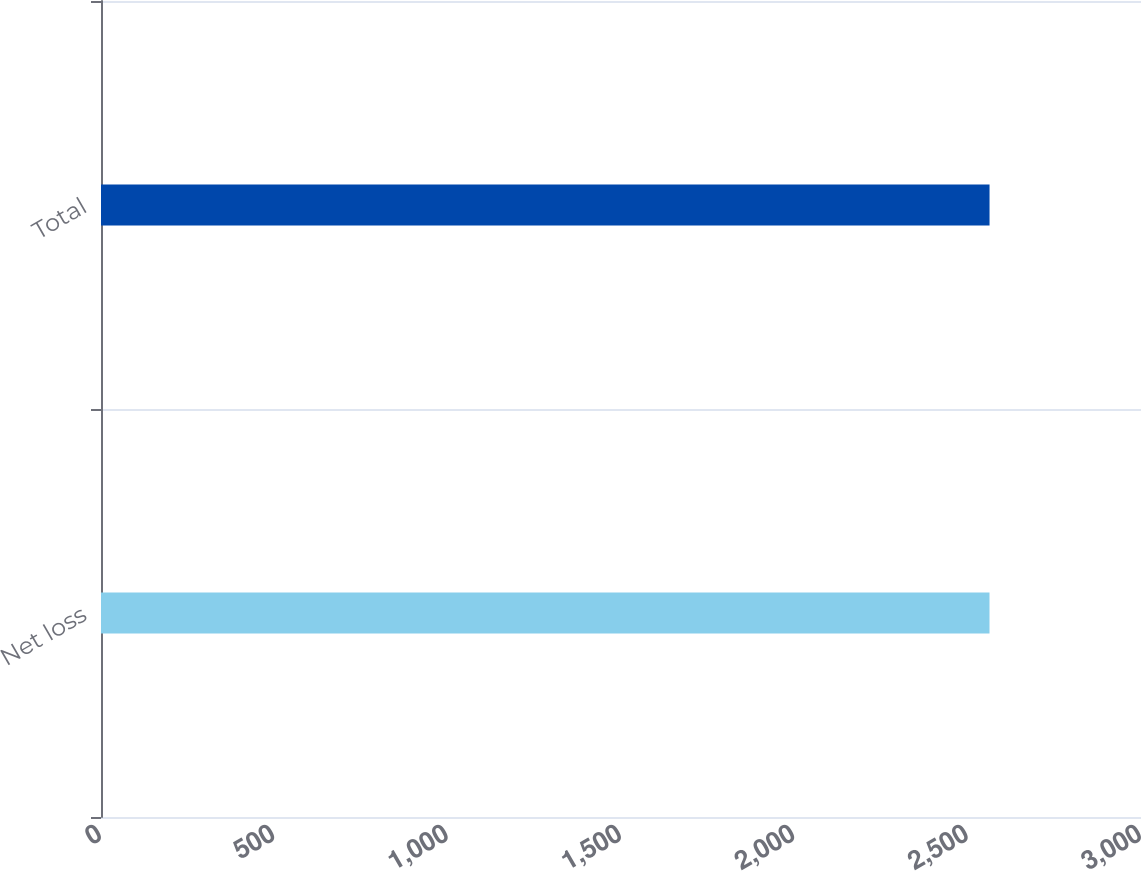<chart> <loc_0><loc_0><loc_500><loc_500><bar_chart><fcel>Net loss<fcel>Total<nl><fcel>2563<fcel>2563.1<nl></chart> 